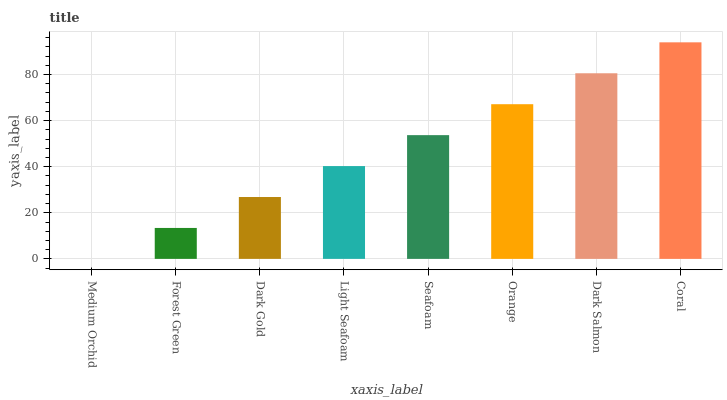Is Medium Orchid the minimum?
Answer yes or no. Yes. Is Coral the maximum?
Answer yes or no. Yes. Is Forest Green the minimum?
Answer yes or no. No. Is Forest Green the maximum?
Answer yes or no. No. Is Forest Green greater than Medium Orchid?
Answer yes or no. Yes. Is Medium Orchid less than Forest Green?
Answer yes or no. Yes. Is Medium Orchid greater than Forest Green?
Answer yes or no. No. Is Forest Green less than Medium Orchid?
Answer yes or no. No. Is Seafoam the high median?
Answer yes or no. Yes. Is Light Seafoam the low median?
Answer yes or no. Yes. Is Orange the high median?
Answer yes or no. No. Is Medium Orchid the low median?
Answer yes or no. No. 